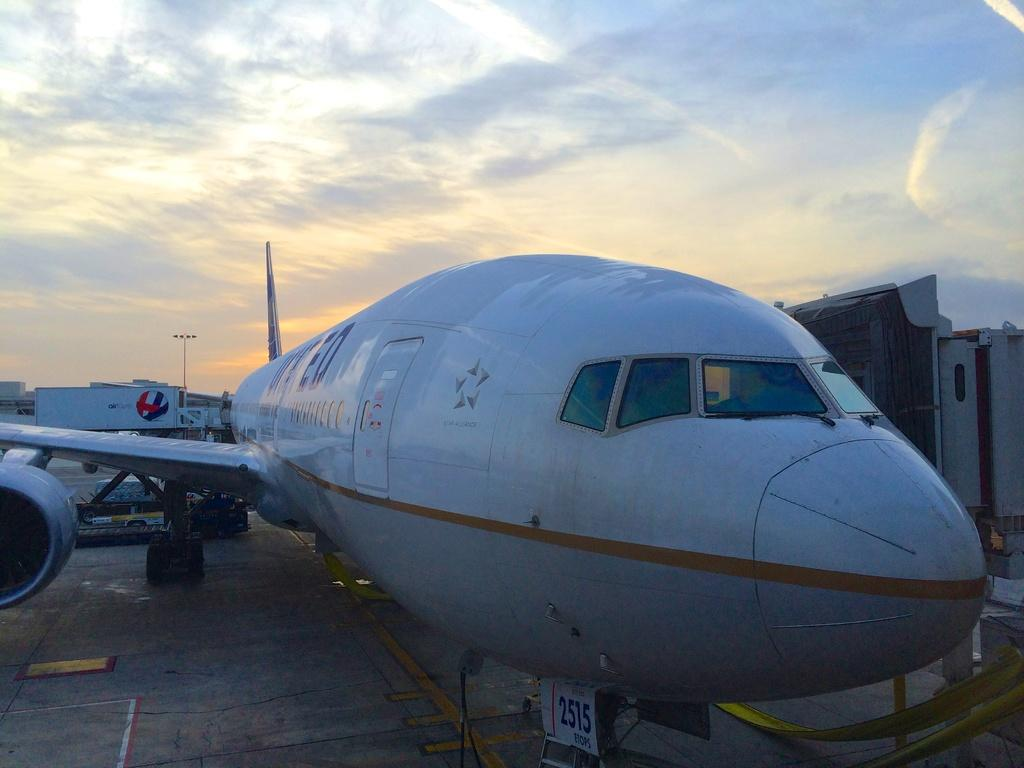What is the main subject in the foreground of the image? There is an airplane in the foreground of the image. Can you describe the position of the airplane in the image? The airplane is on the surface in the image. What can be seen in the background of the image? The sky is visible in the image. What is the condition of the sky in the image? There are clouds in the sky in the image. What type of print can be seen on the airplane's wings in the image? There is no print visible on the airplane's wings in the image. What role does the airplane play in the image? The airplane is the main subject of the image, but it does not have a specific role or action being depicted. 